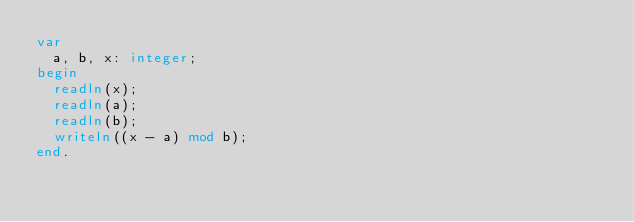<code> <loc_0><loc_0><loc_500><loc_500><_Pascal_>var
  a, b, x: integer;
begin
  readln(x);
  readln(a);
  readln(b);
  writeln((x - a) mod b);
end.</code> 